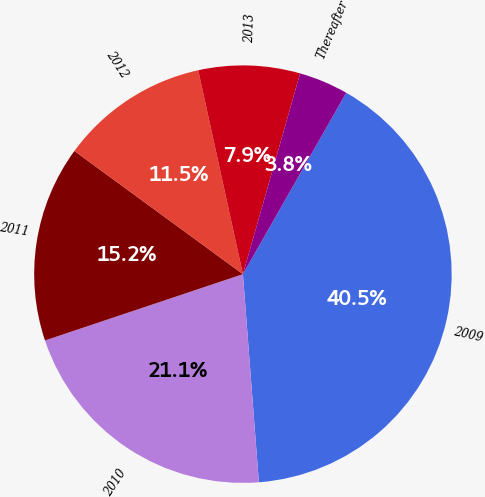Convert chart to OTSL. <chart><loc_0><loc_0><loc_500><loc_500><pie_chart><fcel>2009<fcel>2010<fcel>2011<fcel>2012<fcel>2013<fcel>Thereafter<nl><fcel>40.54%<fcel>21.07%<fcel>15.19%<fcel>11.52%<fcel>7.85%<fcel>3.82%<nl></chart> 